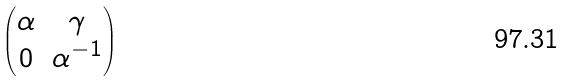<formula> <loc_0><loc_0><loc_500><loc_500>\begin{pmatrix} \alpha & \gamma \\ 0 & \alpha ^ { - 1 } \end{pmatrix}</formula> 